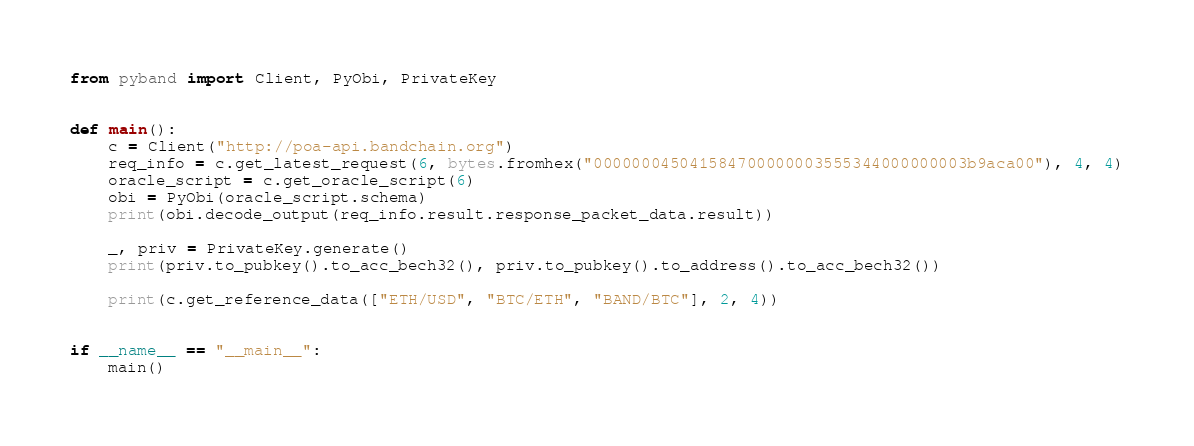Convert code to text. <code><loc_0><loc_0><loc_500><loc_500><_Python_>from pyband import Client, PyObi, PrivateKey


def main():
    c = Client("http://poa-api.bandchain.org")
    req_info = c.get_latest_request(6, bytes.fromhex("000000045041584700000003555344000000003b9aca00"), 4, 4)
    oracle_script = c.get_oracle_script(6)
    obi = PyObi(oracle_script.schema)
    print(obi.decode_output(req_info.result.response_packet_data.result))

    _, priv = PrivateKey.generate()
    print(priv.to_pubkey().to_acc_bech32(), priv.to_pubkey().to_address().to_acc_bech32())

    print(c.get_reference_data(["ETH/USD", "BTC/ETH", "BAND/BTC"], 2, 4))


if __name__ == "__main__":
    main()
</code> 